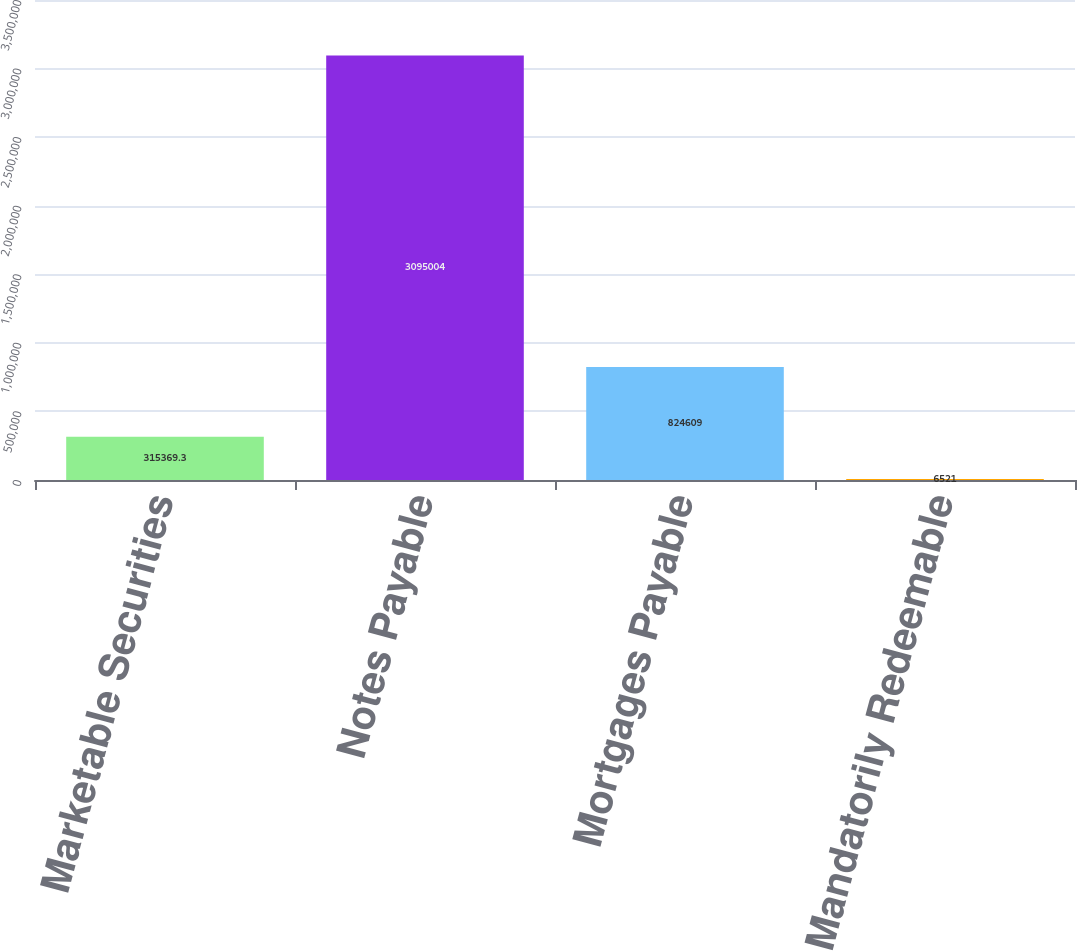Convert chart. <chart><loc_0><loc_0><loc_500><loc_500><bar_chart><fcel>Marketable Securities<fcel>Notes Payable<fcel>Mortgages Payable<fcel>Mandatorily Redeemable<nl><fcel>315369<fcel>3.095e+06<fcel>824609<fcel>6521<nl></chart> 